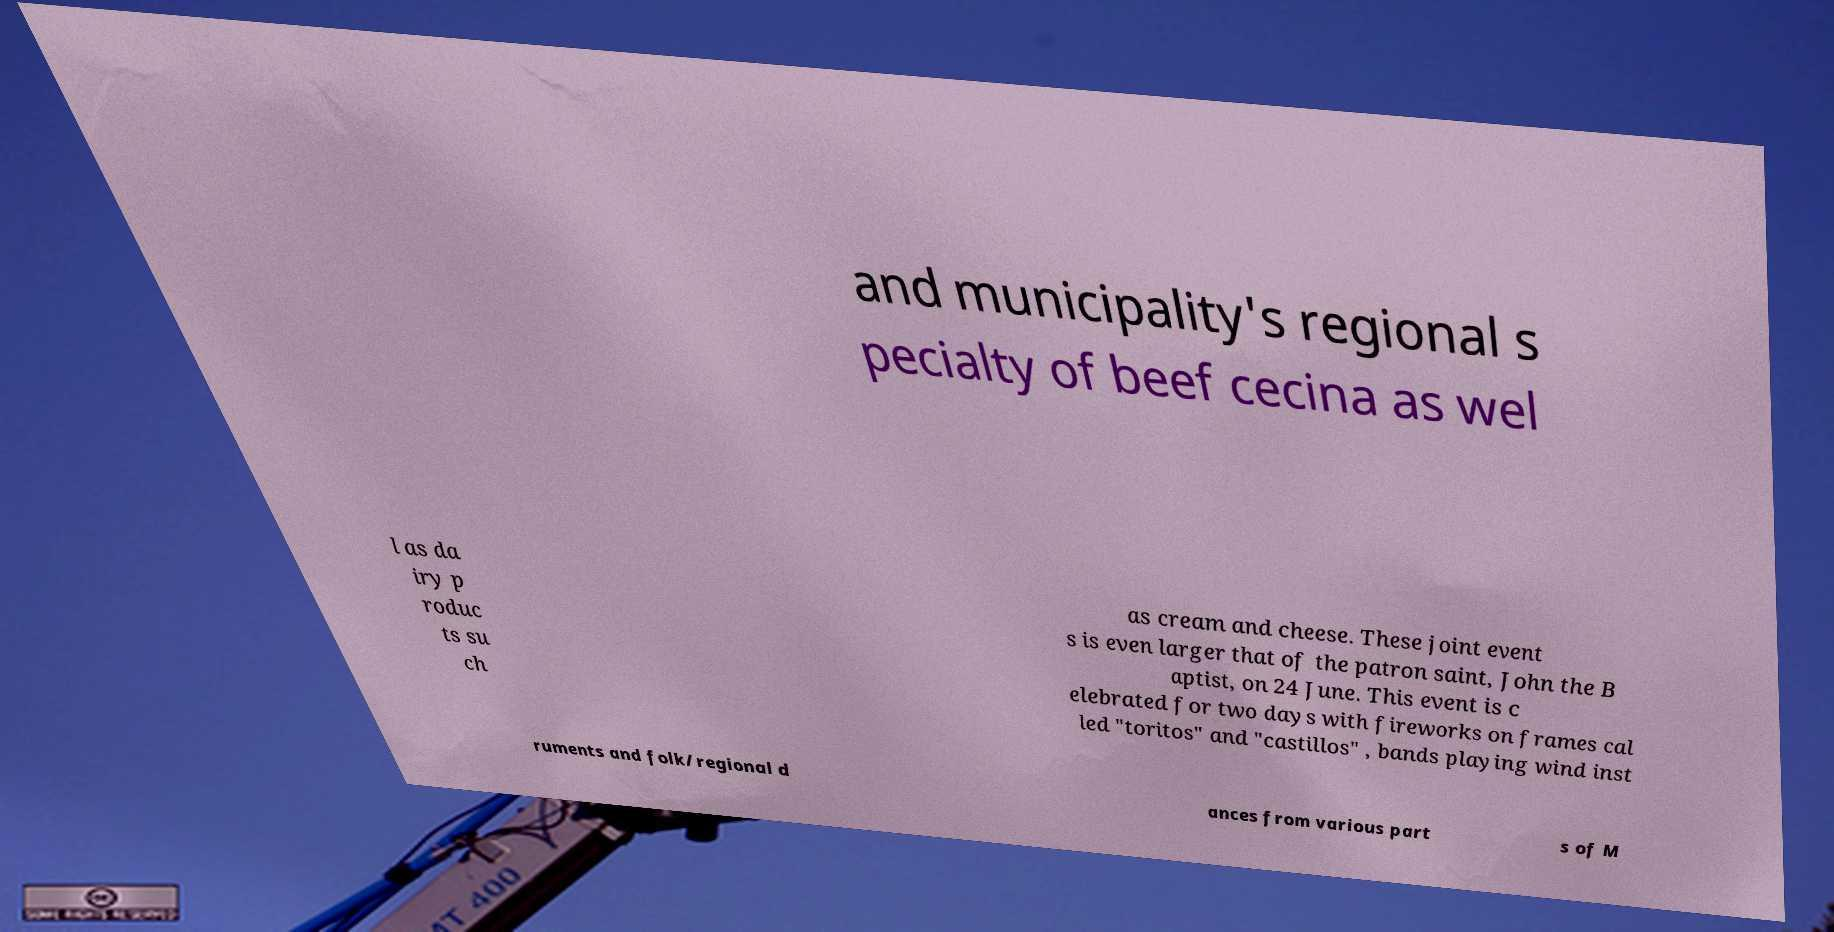Please identify and transcribe the text found in this image. and municipality's regional s pecialty of beef cecina as wel l as da iry p roduc ts su ch as cream and cheese. These joint event s is even larger that of the patron saint, John the B aptist, on 24 June. This event is c elebrated for two days with fireworks on frames cal led "toritos" and "castillos" , bands playing wind inst ruments and folk/regional d ances from various part s of M 